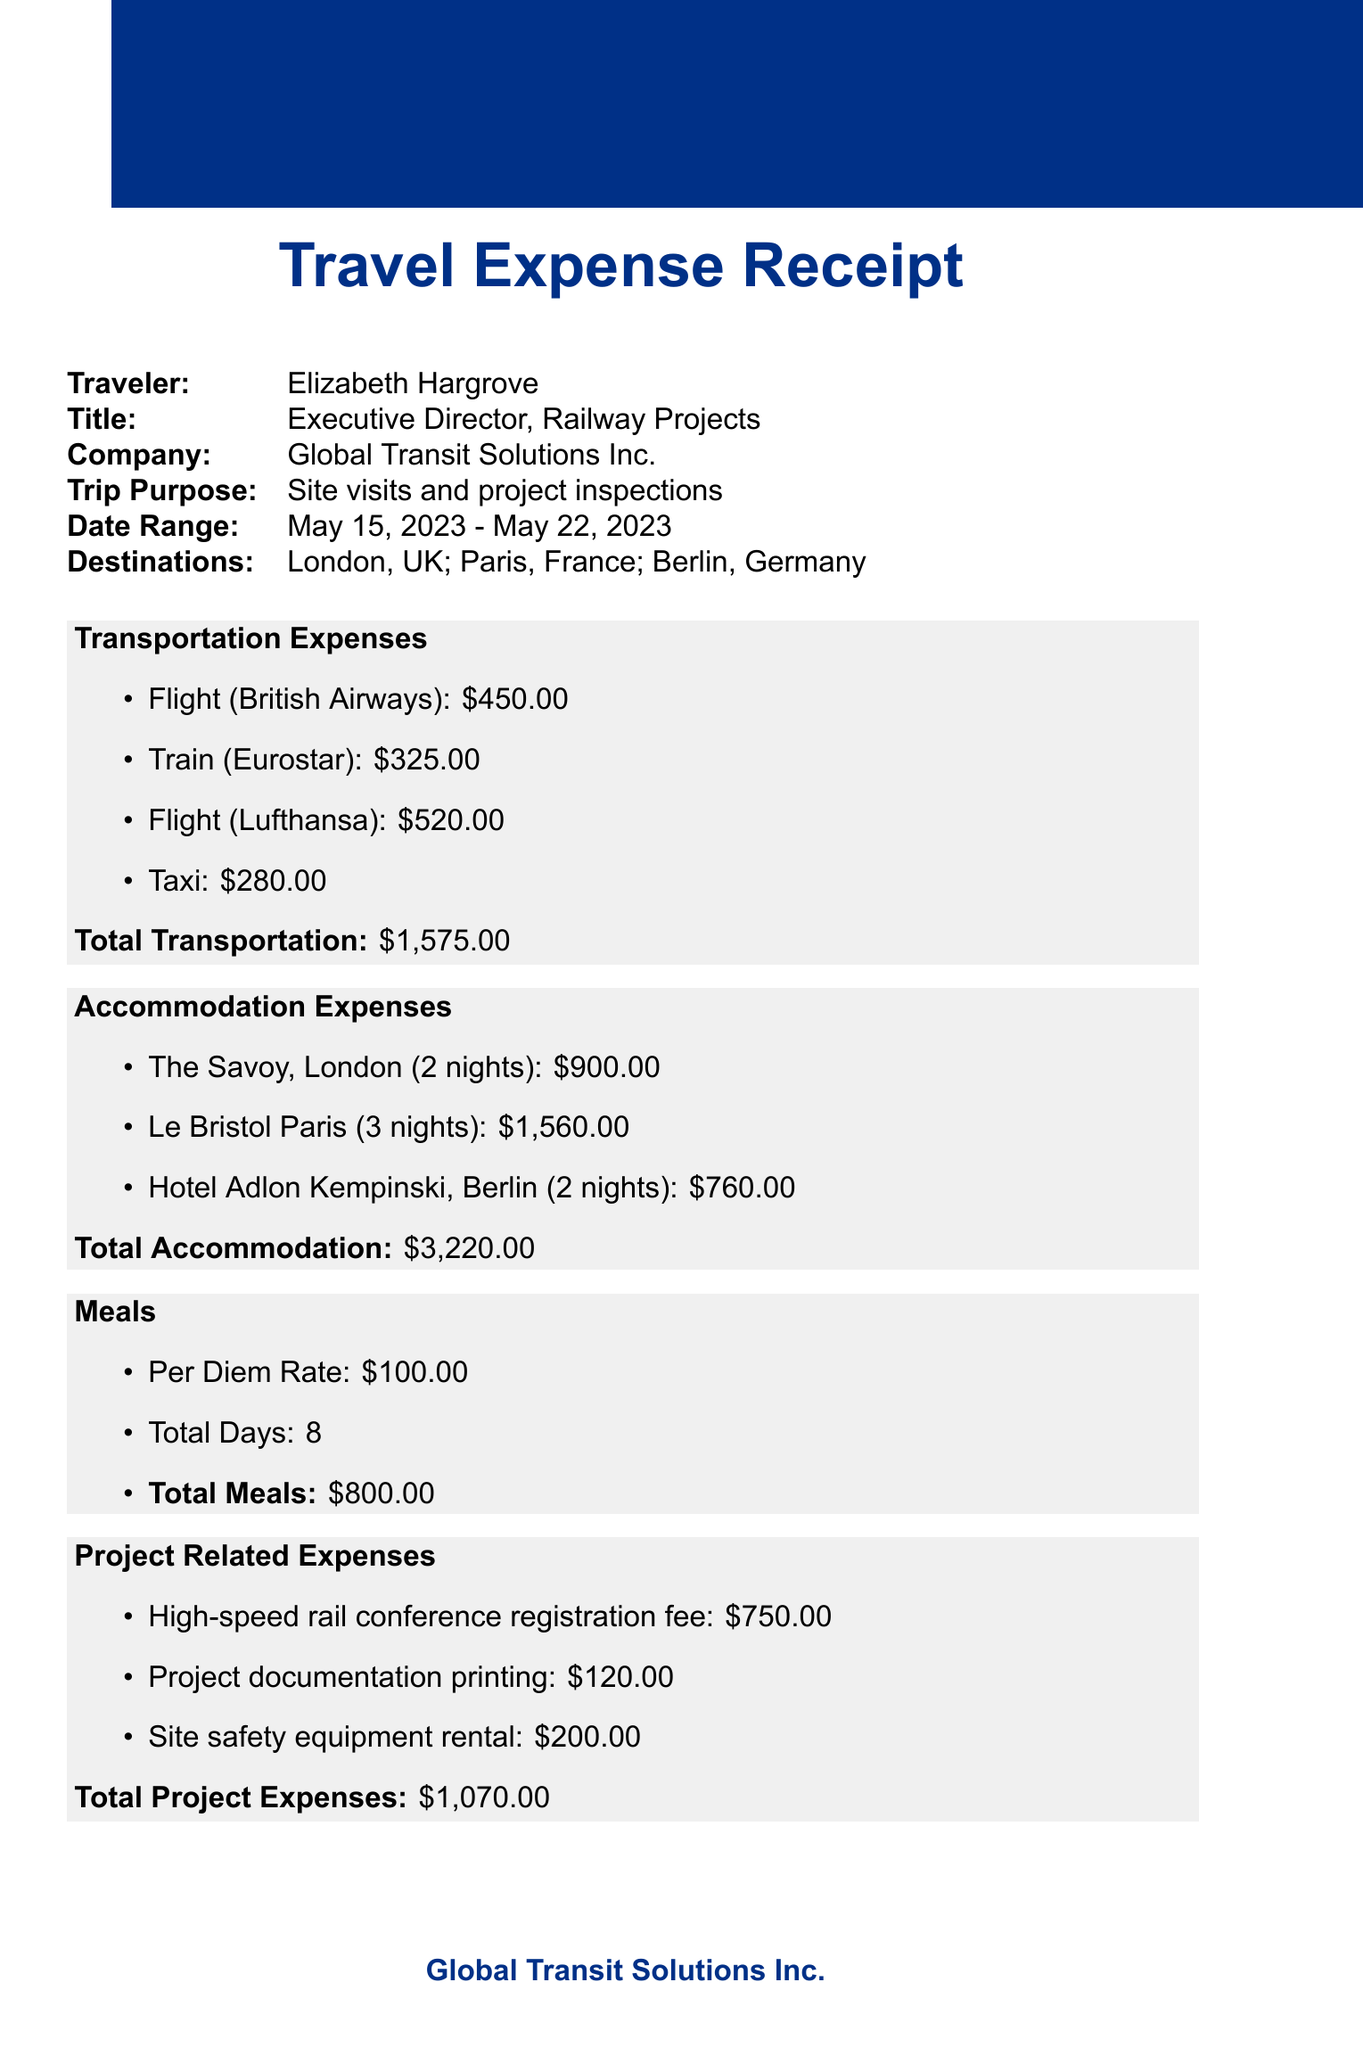What is the name of the traveler? The name of the traveler is stated in the document under the traveler section.
Answer: Elizabeth Hargrove What is the total cost of accommodation? The total cost for accommodation is summed up from the individual hotel costs listed in the document.
Answer: $3,220.00 How many nights did Elizabeth stay in Paris? The number of nights in Paris is specified under the accommodation section.
Answer: 3 What is the purpose of the trip? The purpose of the trip is clearly mentioned in the document under trip details.
Answer: Site visits and project inspections Who approved the expenses? The approver's name is indicated in the approval section of the document.
Answer: Jonathan Blackwell What was the cost of the flight from London to Berlin? The cost of the flight from London to Berlin is specifically stated in the transportation expenses.
Answer: $520.00 What is the total amount claimed for meals? The total amount for meals is calculated based on the per diem rate and total days listed in the document.
Answer: $800.00 What was the registration fee for the conference? The registration fee for the conference is mentioned under project related expenses.
Answer: $750.00 What were the miscellaneous expenses? The miscellaneous expenses are listed and detailed in the specified section of the document.
Answer: $275.00 